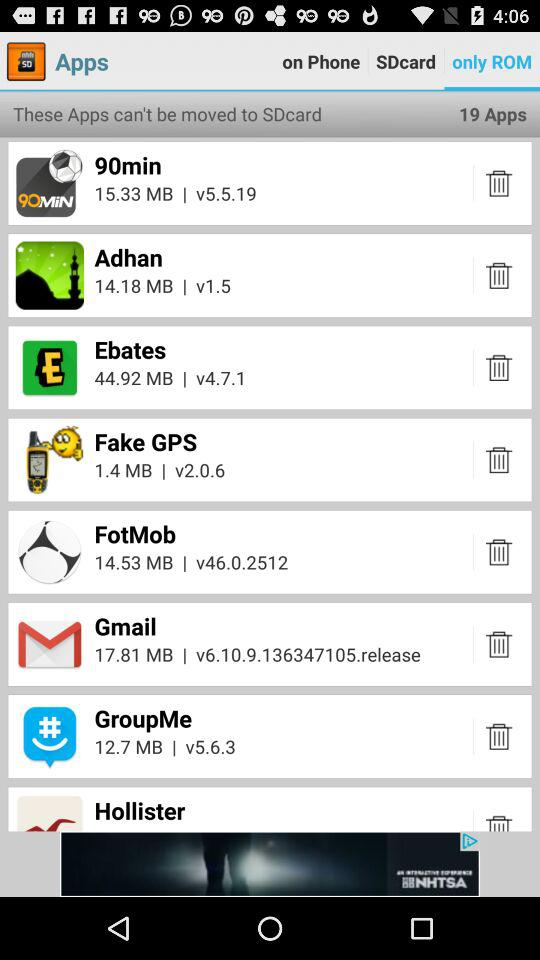What is the version of "GroupMe"? The version is v5.6.3. 